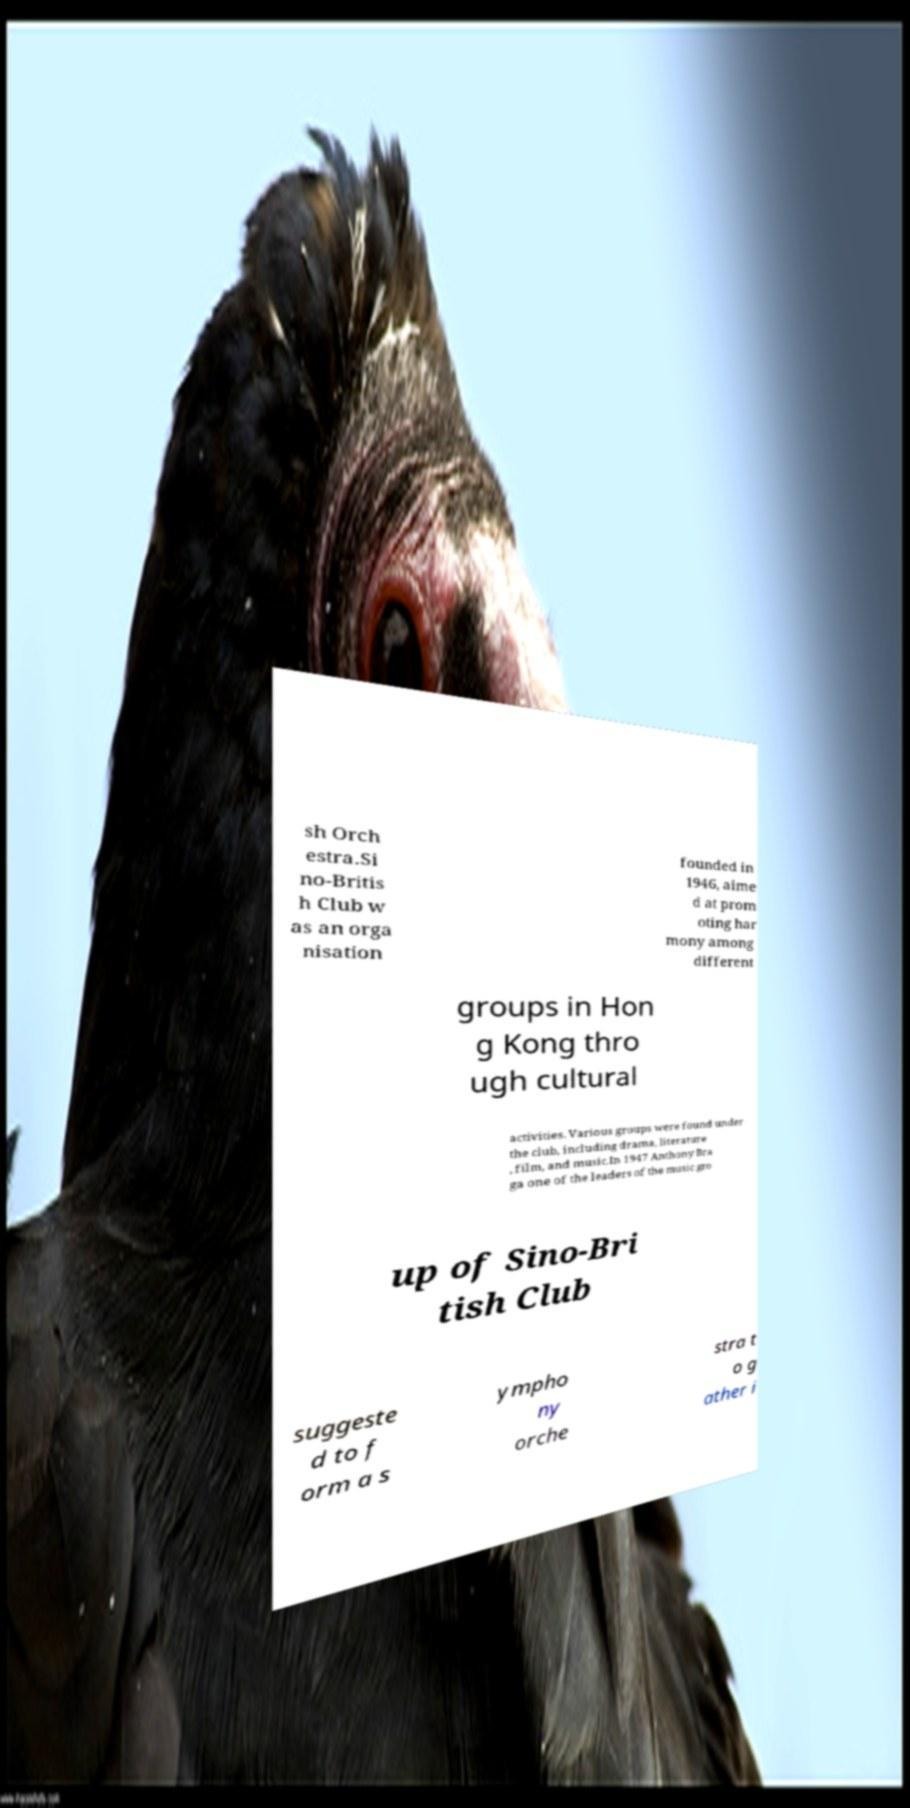Can you read and provide the text displayed in the image?This photo seems to have some interesting text. Can you extract and type it out for me? sh Orch estra.Si no-Britis h Club w as an orga nisation founded in 1946, aime d at prom oting har mony among different groups in Hon g Kong thro ugh cultural activities. Various groups were found under the club, including drama, literature , film, and music.In 1947 Anthony Bra ga one of the leaders of the music gro up of Sino-Bri tish Club suggeste d to f orm a s ympho ny orche stra t o g ather i 